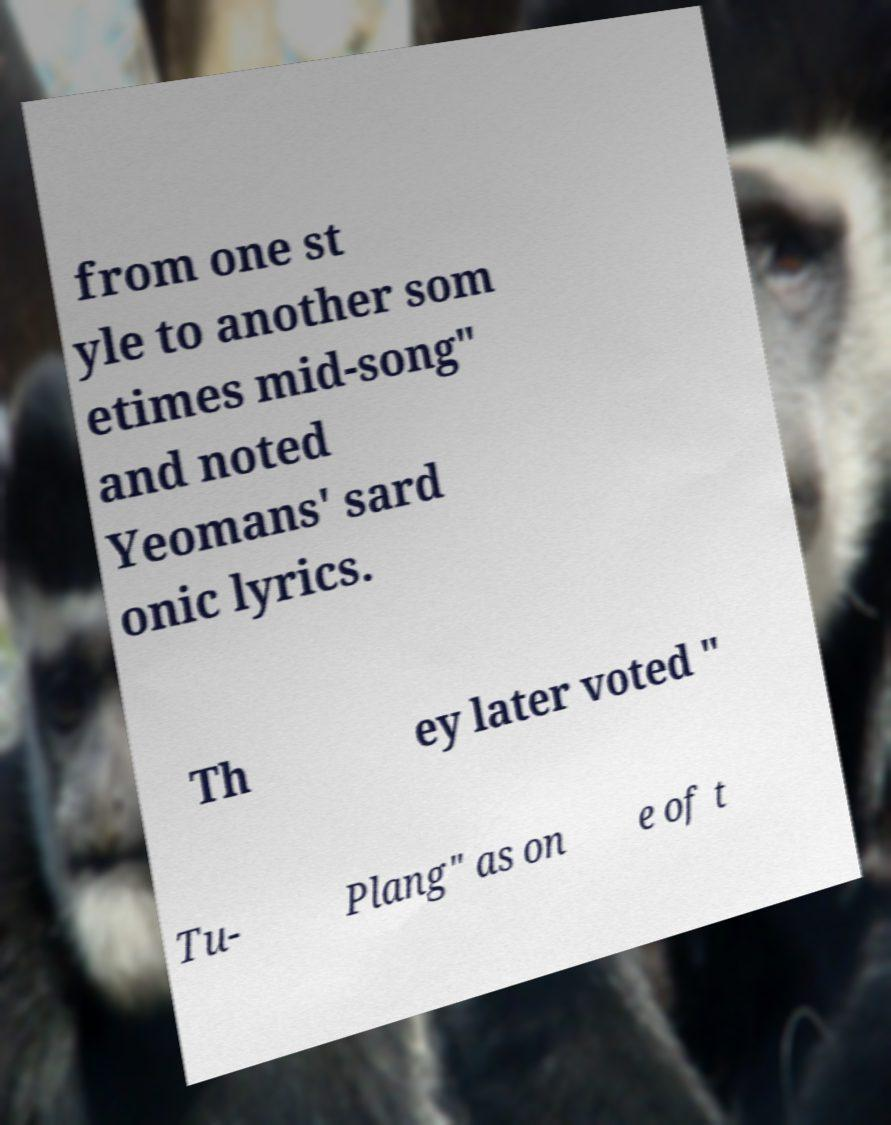Could you assist in decoding the text presented in this image and type it out clearly? from one st yle to another som etimes mid-song" and noted Yeomans' sard onic lyrics. Th ey later voted " Tu- Plang" as on e of t 